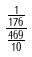Convert formula to latex. <formula><loc_0><loc_0><loc_500><loc_500>\frac { \frac { 1 } { 1 7 6 } } { \frac { 4 6 9 } { 1 0 } }</formula> 